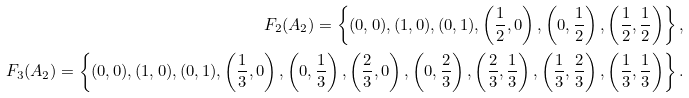Convert formula to latex. <formula><loc_0><loc_0><loc_500><loc_500>F _ { 2 } ( A _ { 2 } ) = \left \{ ( 0 , 0 ) , ( 1 , 0 ) , ( 0 , 1 ) , \left ( \frac { 1 } { 2 } , 0 \right ) , \left ( 0 , \frac { 1 } { 2 } \right ) , \left ( \frac { 1 } { 2 } , \frac { 1 } { 2 } \right ) \right \} , \\ F _ { 3 } ( A _ { 2 } ) = \left \{ ( 0 , 0 ) , ( 1 , 0 ) , ( 0 , 1 ) , \left ( \frac { 1 } { 3 } , 0 \right ) , \left ( 0 , \frac { 1 } { 3 } \right ) , \left ( \frac { 2 } { 3 } , 0 \right ) , \left ( 0 , \frac { 2 } { 3 } \right ) , \left ( \frac { 2 } { 3 } , \frac { 1 } { 3 } \right ) , \left ( \frac { 1 } { 3 } , \frac { 2 } { 3 } \right ) , \left ( \frac { 1 } { 3 } , \frac { 1 } { 3 } \right ) \right \} .</formula> 